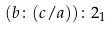<formula> <loc_0><loc_0><loc_500><loc_500>( b \colon ( c / a ) ) \colon 2 _ { 1 }</formula> 